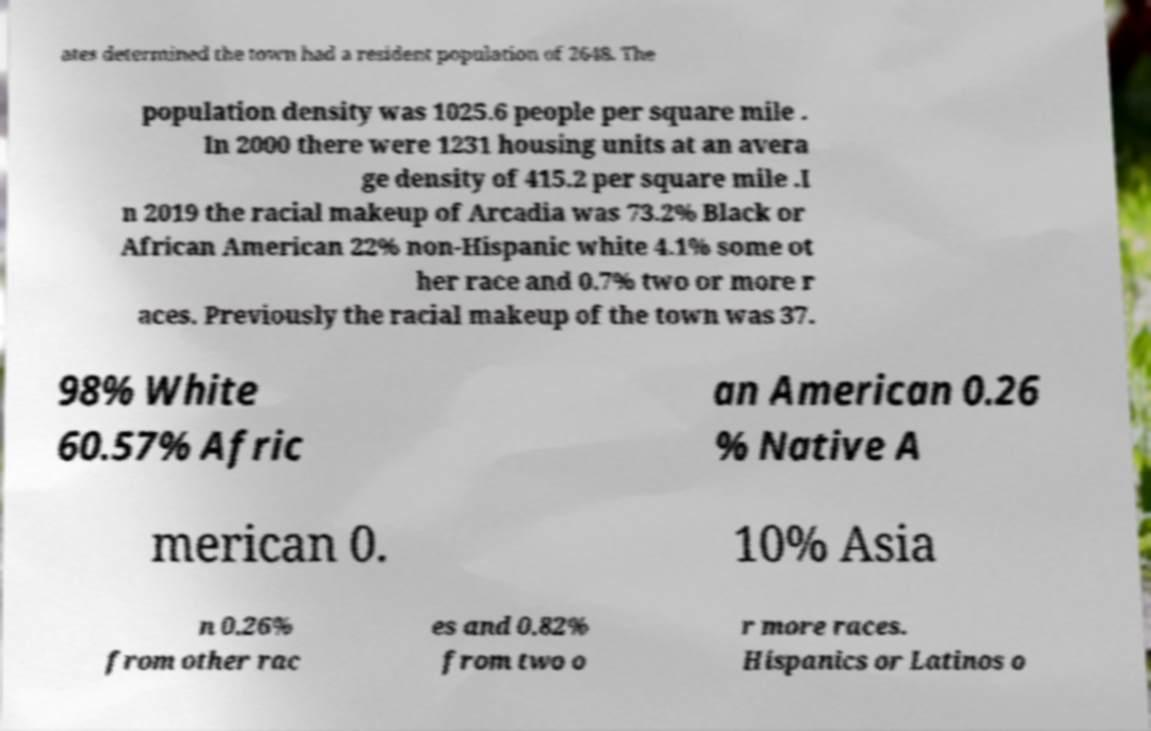I need the written content from this picture converted into text. Can you do that? ates determined the town had a resident population of 2648. The population density was 1025.6 people per square mile . In 2000 there were 1231 housing units at an avera ge density of 415.2 per square mile .I n 2019 the racial makeup of Arcadia was 73.2% Black or African American 22% non-Hispanic white 4.1% some ot her race and 0.7% two or more r aces. Previously the racial makeup of the town was 37. 98% White 60.57% Afric an American 0.26 % Native A merican 0. 10% Asia n 0.26% from other rac es and 0.82% from two o r more races. Hispanics or Latinos o 